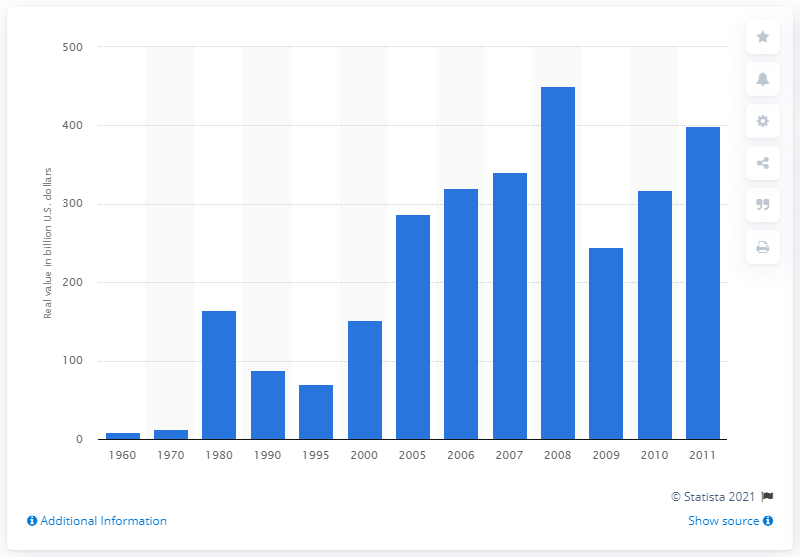Identify some key points in this picture. In 2000, the actual worth of fossil fuel imports was 151.95. In 2005, the buying power of fossil fuel imports relative to the dollar was significant. 